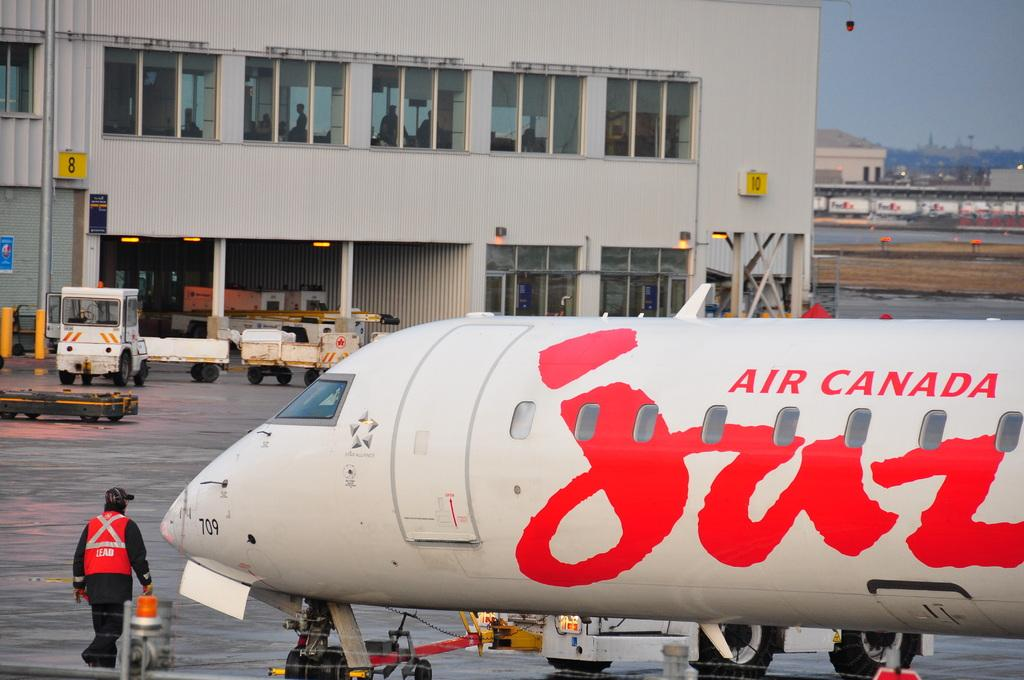<image>
Create a compact narrative representing the image presented. an airport with a man and a plane with AIR CANADA on it. 